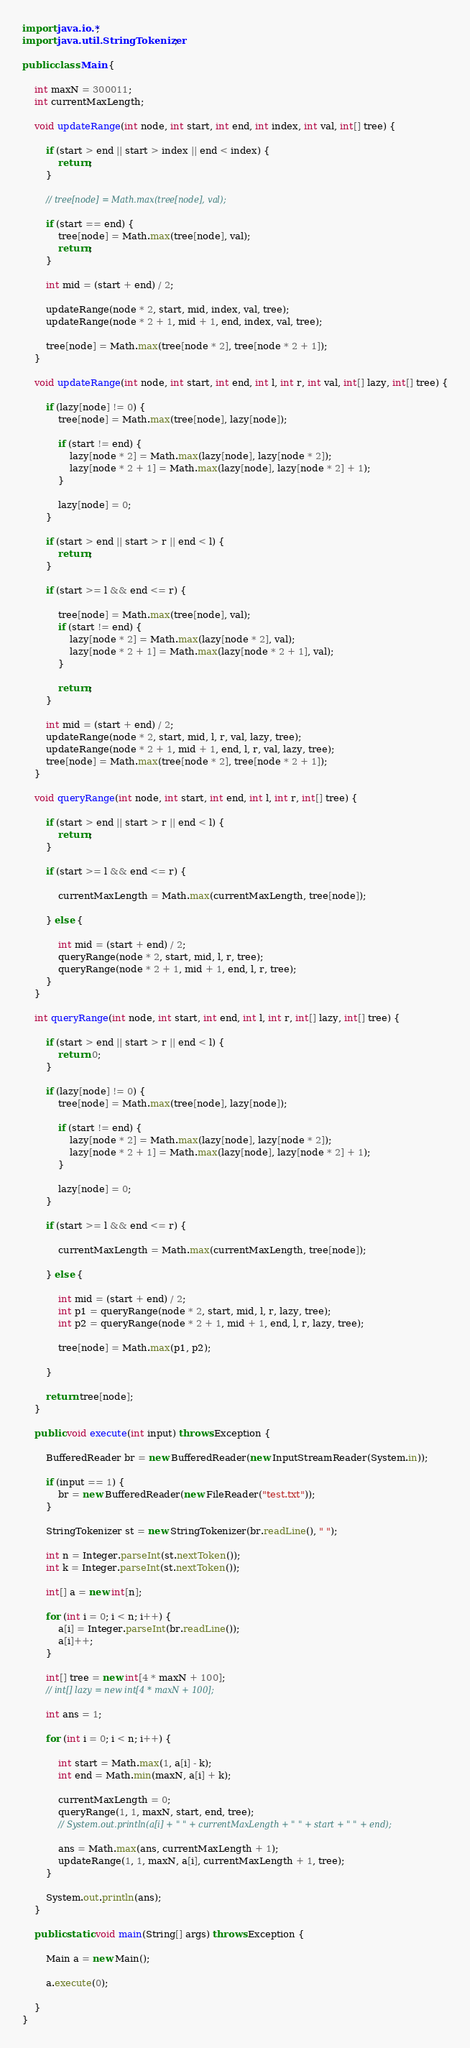Convert code to text. <code><loc_0><loc_0><loc_500><loc_500><_Java_>import java.io.*;
import java.util.StringTokenizer;

public class Main {

	int maxN = 300011;
	int currentMaxLength;

	void updateRange(int node, int start, int end, int index, int val, int[] tree) {

		if (start > end || start > index || end < index) {
			return;
		}

		// tree[node] = Math.max(tree[node], val);
		
		if (start == end) {
			tree[node] = Math.max(tree[node], val);
			return;
		}

		int mid = (start + end) / 2;
		
		updateRange(node * 2, start, mid, index, val, tree);
		updateRange(node * 2 + 1, mid + 1, end, index, val, tree);
		
		tree[node] = Math.max(tree[node * 2], tree[node * 2 + 1]);
	}

	void updateRange(int node, int start, int end, int l, int r, int val, int[] lazy, int[] tree) {

		if (lazy[node] != 0) {
			tree[node] = Math.max(tree[node], lazy[node]);

			if (start != end) {
				lazy[node * 2] = Math.max(lazy[node], lazy[node * 2]);
				lazy[node * 2 + 1] = Math.max(lazy[node], lazy[node * 2] + 1);
			}

			lazy[node] = 0;
		}

		if (start > end || start > r || end < l) {
			return;
		}

		if (start >= l && end <= r) {

			tree[node] = Math.max(tree[node], val);
			if (start != end) {
				lazy[node * 2] = Math.max(lazy[node * 2], val);
				lazy[node * 2 + 1] = Math.max(lazy[node * 2 + 1], val);
			}

			return;
		}

		int mid = (start + end) / 2;
		updateRange(node * 2, start, mid, l, r, val, lazy, tree);
		updateRange(node * 2 + 1, mid + 1, end, l, r, val, lazy, tree);
		tree[node] = Math.max(tree[node * 2], tree[node * 2 + 1]);
	}

	void queryRange(int node, int start, int end, int l, int r, int[] tree) {

		if (start > end || start > r || end < l) {
			return;
		}

		if (start >= l && end <= r) {

			currentMaxLength = Math.max(currentMaxLength, tree[node]);

		} else {

			int mid = (start + end) / 2;
			queryRange(node * 2, start, mid, l, r, tree);
			queryRange(node * 2 + 1, mid + 1, end, l, r, tree);
		}
	}

	int queryRange(int node, int start, int end, int l, int r, int[] lazy, int[] tree) {

		if (start > end || start > r || end < l) {
			return 0;
		}

		if (lazy[node] != 0) {
			tree[node] = Math.max(tree[node], lazy[node]);

			if (start != end) {
				lazy[node * 2] = Math.max(lazy[node], lazy[node * 2]);
				lazy[node * 2 + 1] = Math.max(lazy[node], lazy[node * 2] + 1);
			}

			lazy[node] = 0;
		}

		if (start >= l && end <= r) {

			currentMaxLength = Math.max(currentMaxLength, tree[node]);

		} else {

			int mid = (start + end) / 2;
			int p1 = queryRange(node * 2, start, mid, l, r, lazy, tree);
			int p2 = queryRange(node * 2 + 1, mid + 1, end, l, r, lazy, tree);

			tree[node] = Math.max(p1, p2);

		}

		return tree[node];
	}

	public void execute(int input) throws Exception {

		BufferedReader br = new BufferedReader(new InputStreamReader(System.in));

		if (input == 1) {
			br = new BufferedReader(new FileReader("test.txt"));
		}

		StringTokenizer st = new StringTokenizer(br.readLine(), " ");

		int n = Integer.parseInt(st.nextToken());
		int k = Integer.parseInt(st.nextToken());

		int[] a = new int[n];

		for (int i = 0; i < n; i++) {
			a[i] = Integer.parseInt(br.readLine());
			a[i]++;
		}

		int[] tree = new int[4 * maxN + 100];
		// int[] lazy = new int[4 * maxN + 100];

		int ans = 1;

		for (int i = 0; i < n; i++) {

			int start = Math.max(1, a[i] - k);
			int end = Math.min(maxN, a[i] + k);

			currentMaxLength = 0;
			queryRange(1, 1, maxN, start, end, tree);
			// System.out.println(a[i] + " " + currentMaxLength + " " + start + " " + end);

			ans = Math.max(ans, currentMaxLength + 1);
			updateRange(1, 1, maxN, a[i], currentMaxLength + 1, tree);
		}

		System.out.println(ans);
	}

	public static void main(String[] args) throws Exception {

		Main a = new Main();

		a.execute(0);

	}
}
</code> 